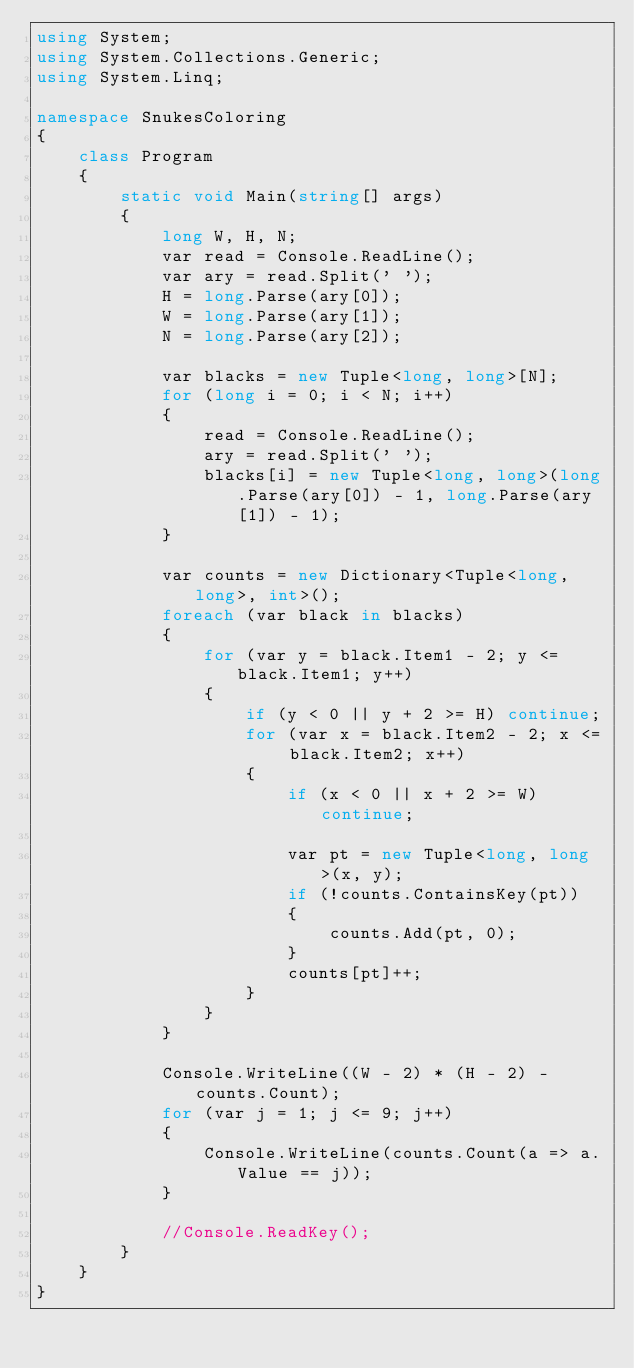<code> <loc_0><loc_0><loc_500><loc_500><_C#_>using System;
using System.Collections.Generic;
using System.Linq;

namespace SnukesColoring
{
    class Program
    {
        static void Main(string[] args)
        {
            long W, H, N;
            var read = Console.ReadLine();
            var ary = read.Split(' ');
            H = long.Parse(ary[0]);
            W = long.Parse(ary[1]);
            N = long.Parse(ary[2]);

            var blacks = new Tuple<long, long>[N];
            for (long i = 0; i < N; i++)
            {
                read = Console.ReadLine();
                ary = read.Split(' ');
                blacks[i] = new Tuple<long, long>(long.Parse(ary[0]) - 1, long.Parse(ary[1]) - 1);
            }

            var counts = new Dictionary<Tuple<long, long>, int>();
            foreach (var black in blacks)
            {
                for (var y = black.Item1 - 2; y <= black.Item1; y++)
                {
                    if (y < 0 || y + 2 >= H) continue;
                    for (var x = black.Item2 - 2; x <= black.Item2; x++)
                    {
                        if (x < 0 || x + 2 >= W) continue;

                        var pt = new Tuple<long, long>(x, y);
                        if (!counts.ContainsKey(pt))
                        {
                            counts.Add(pt, 0);
                        }
                        counts[pt]++;
                    }
                }
            }

            Console.WriteLine((W - 2) * (H - 2) - counts.Count);
            for (var j = 1; j <= 9; j++)
            {
                Console.WriteLine(counts.Count(a => a.Value == j));
            }

            //Console.ReadKey();
        }
    }
}
</code> 